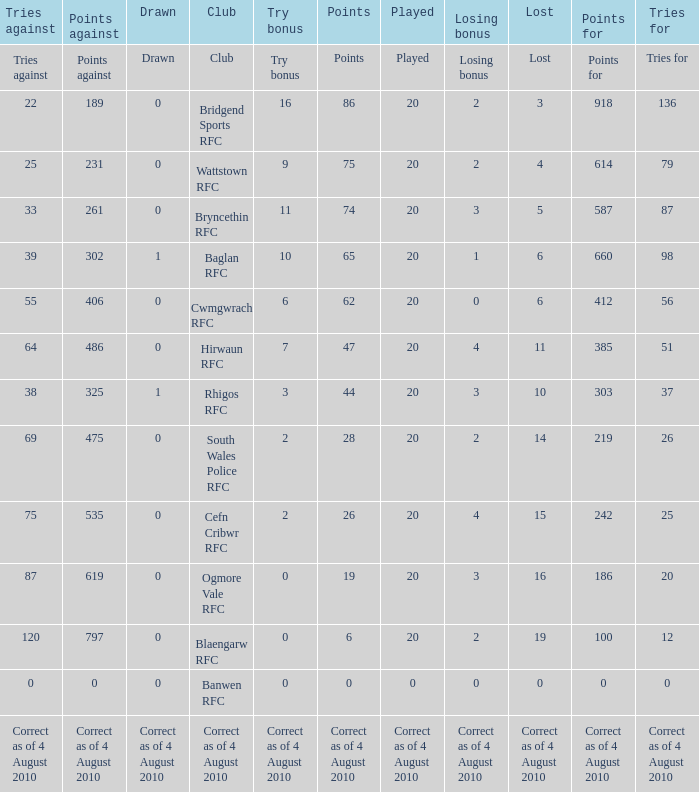What is the points against when the losing bonus is 0 and the club is banwen rfc? 0.0. 